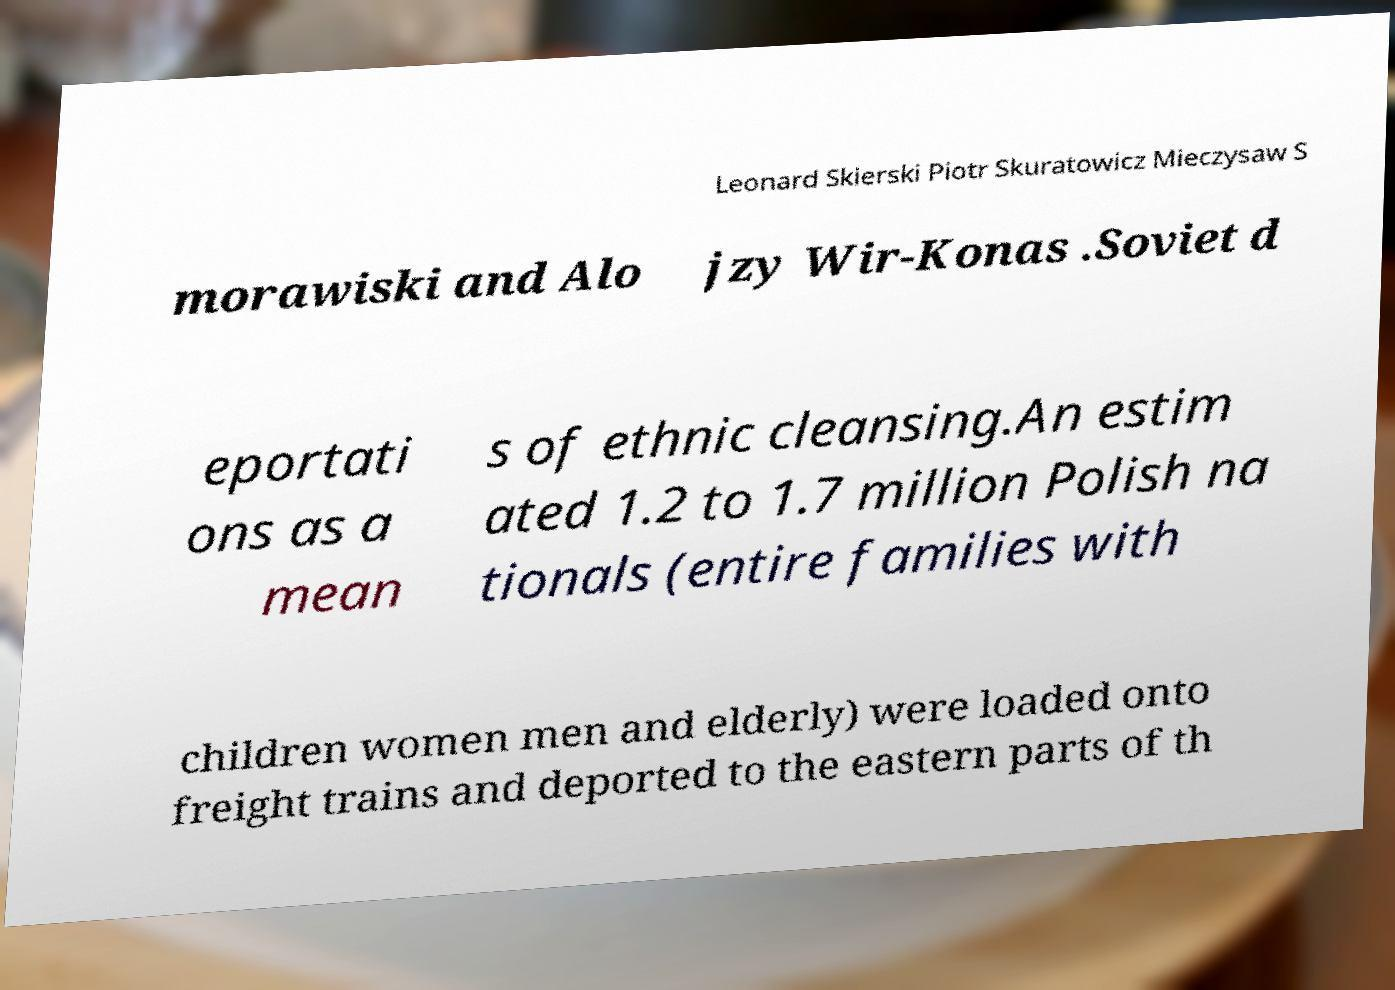What messages or text are displayed in this image? I need them in a readable, typed format. Leonard Skierski Piotr Skuratowicz Mieczysaw S morawiski and Alo jzy Wir-Konas .Soviet d eportati ons as a mean s of ethnic cleansing.An estim ated 1.2 to 1.7 million Polish na tionals (entire families with children women men and elderly) were loaded onto freight trains and deported to the eastern parts of th 